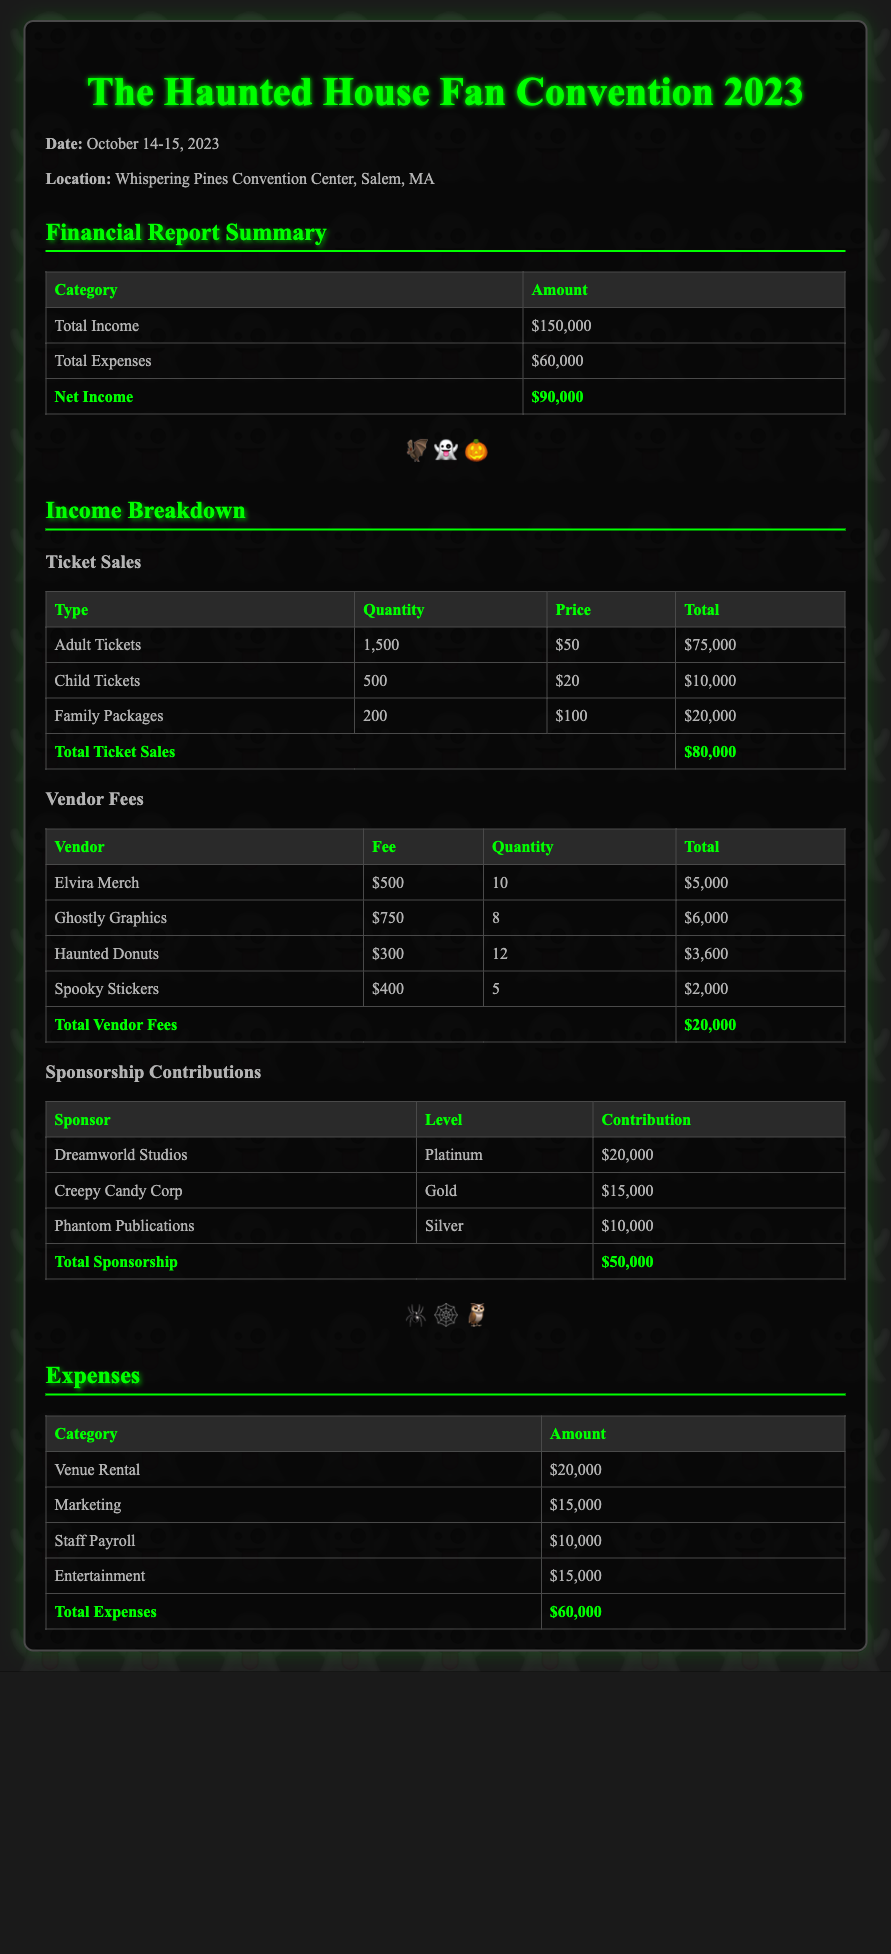what is the total income? The total income is presented in the financial report summary section, which states that the total income is $150,000.
Answer: $150,000 how much was earned from ticket sales? The total from ticket sales is located in the income breakdown section under "Total Ticket Sales," which shows $80,000.
Answer: $80,000 what is the contribution from Dreamworld Studios? Dreamworld Studios' contribution is detailed in the sponsorship contributions section, listed as $20,000.
Answer: $20,000 how many adult tickets were sold? The number of adult tickets sold is specified in the ticket sales table, which indicates 1,500 adult tickets.
Answer: 1,500 what is the total amount earned from vendor fees? The document lists the total vendor fees under the vendor fees section, which amounts to $20,000.
Answer: $20,000 what is the net income for the convention? The net income is determined by subtracting total expenses from total income, stated as $90,000 in the financial report summary.
Answer: $90,000 how many family packages were sold? The family packages sold are noted in the ticket sales table, showing a quantity of 200.
Answer: 200 what is the total expenses incurred? The total expenses are specified in the financial report summary section, which indicates $60,000.
Answer: $60,000 which vendor has the highest fee? Among the listed vendors, Ghostly Graphics have the highest fee at $750.
Answer: $750 